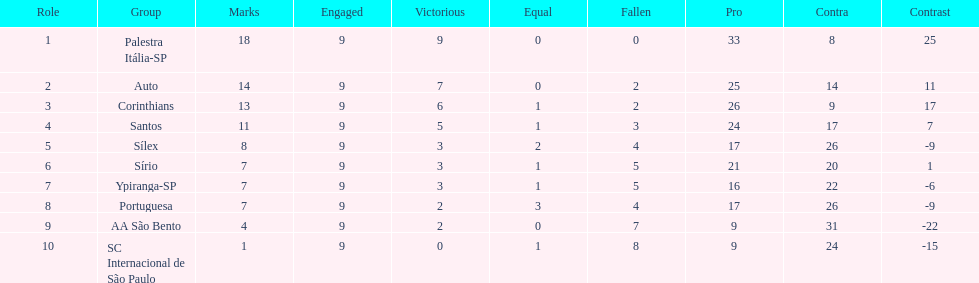How many points did the brazilian football team auto get in 1926? 14. 